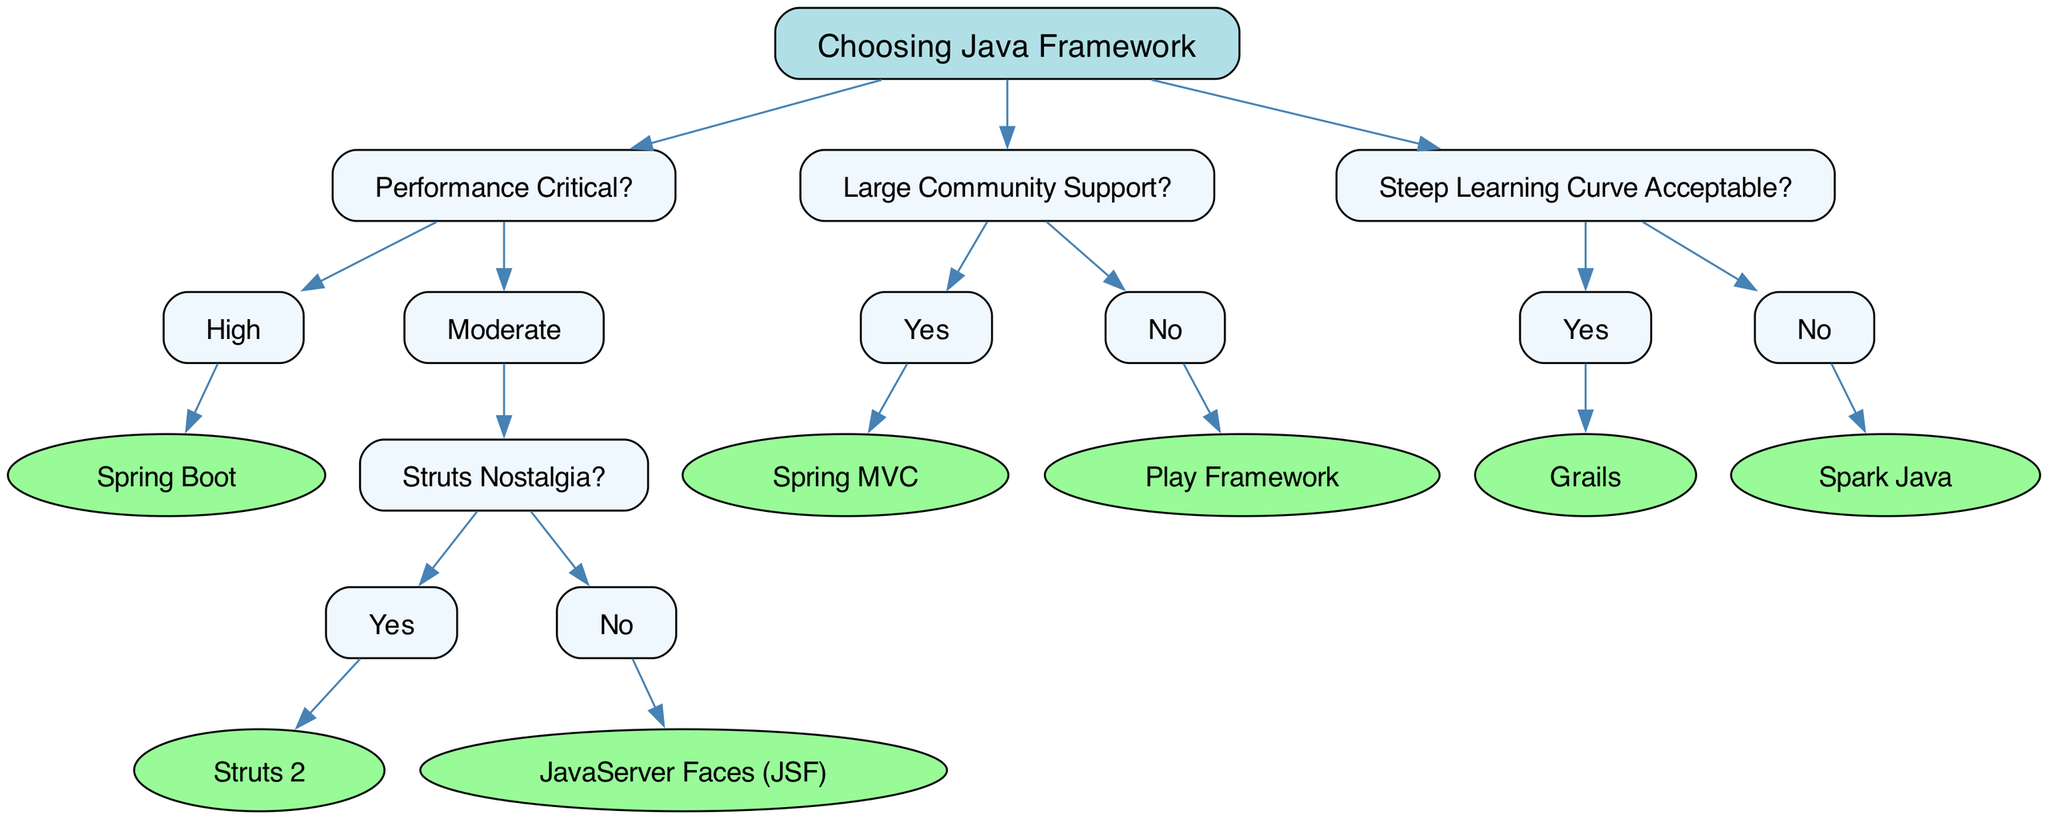What is the root node of the decision tree? The root node represents the central question of the decision-making process, which is "Choosing Java Framework."
Answer: Choosing Java Framework How many nodes are directly under the performance node? The performance node has two children: "High" and "Moderate." Hence, there are two direct nodes.
Answer: 2 What is the framework recommended for high performance? The framework recommended in the decision tree for high performance is "Spring Boot."
Answer: Spring Boot If a developer wants large community support but does not want to use Spring MVC, which framework can they choose? From the "Large Community Support?" node, if the answer is "No," the option then becomes "Play Framework."
Answer: Play Framework What framework is suggested if the developer chooses "Moderate" performance and has Struts nostalgia? In the decision branch that starts with "Moderate" performance, and if "Struts Nostalgia?" is answered with "Yes," the recommendation is "Struts 2."
Answer: Struts 2 If steep learning curves are not acceptable, which framework is recommended? The diagram indicates that for "No" under "Steep Learning Curve Acceptable?," the suggested framework is "Spark Java."
Answer: Spark Java What is the relationship between "Spring MVC" and "Large Community Support?" "Spring MVC" is a child node of "Large Community Support?" implying that if there is large community support, it recommends "Spring MVC."
Answer: Child node How many frameworks are listed as options for high performance? According to the decision tree, there is only one framework listed for high performance, which is "Spring Boot."
Answer: 1 Which node offers a choice between using Struts 2 and JavaServer Faces? The choice between "Struts 2" and "JavaServer Faces (JSF)" originates from the "Struts Nostalgia?" node that follows the "Moderate" performance.
Answer: Struts Nostalgia 